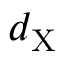<formula> <loc_0><loc_0><loc_500><loc_500>d _ { X }</formula> 